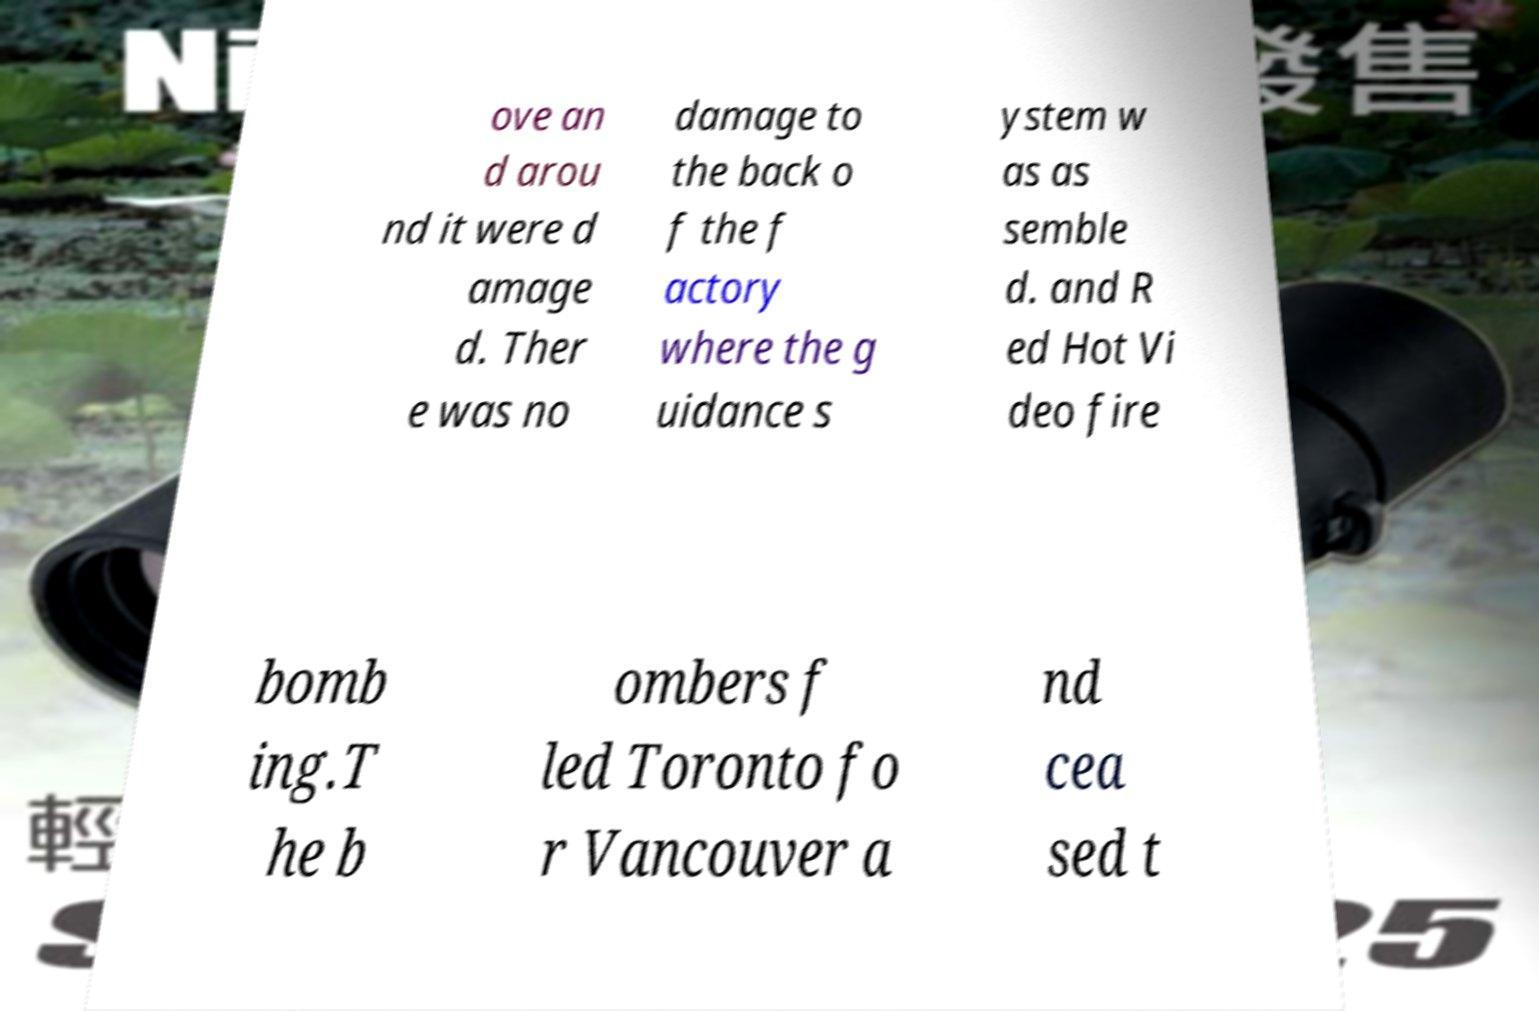There's text embedded in this image that I need extracted. Can you transcribe it verbatim? ove an d arou nd it were d amage d. Ther e was no damage to the back o f the f actory where the g uidance s ystem w as as semble d. and R ed Hot Vi deo fire bomb ing.T he b ombers f led Toronto fo r Vancouver a nd cea sed t 